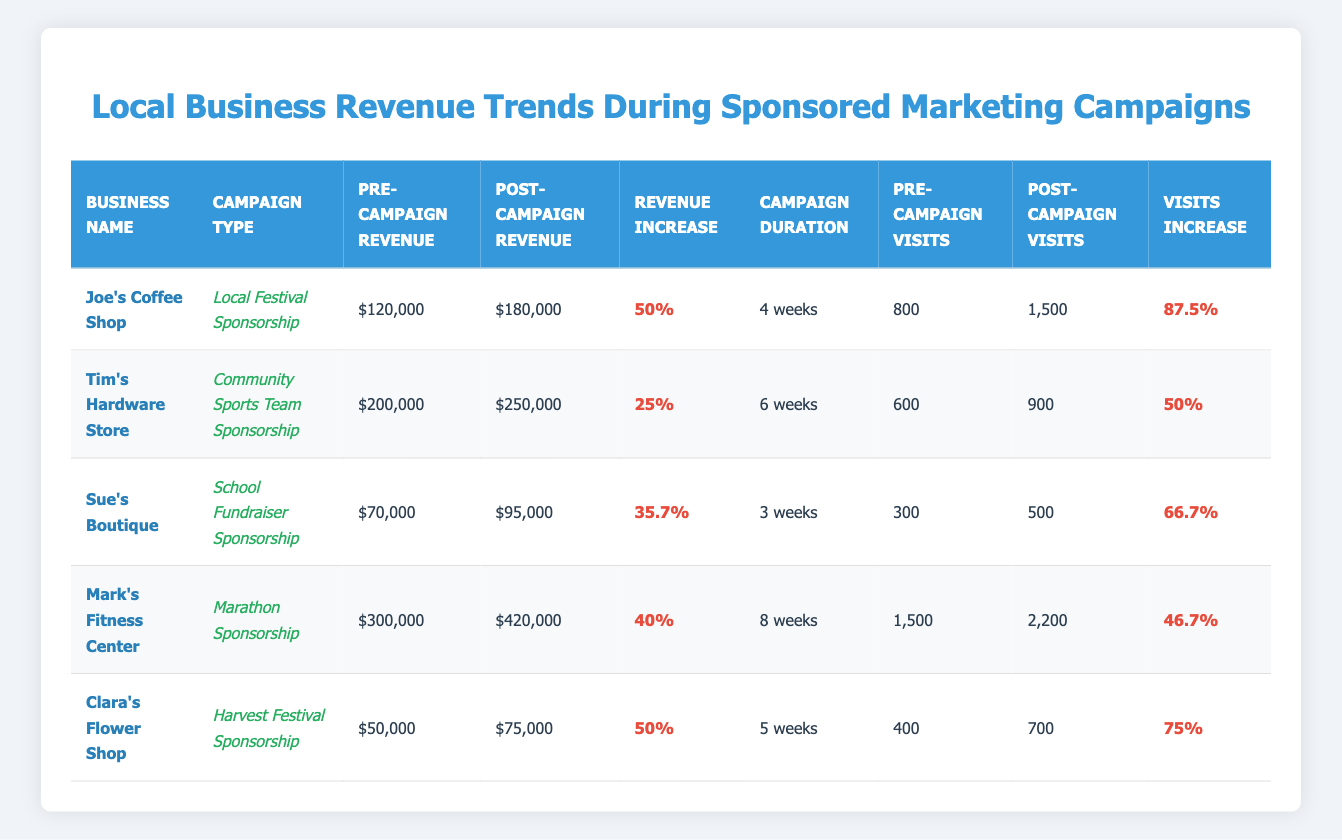What was the pre-campaign revenue for Joe's Coffee Shop? The table clearly shows that Joe's Coffee Shop had a pre-campaign revenue of $120,000 in the respective column.
Answer: 120000 Which business had the highest increase in customer visits? Observing the "Visits Increase" column, Joe's Coffee Shop shows a significant increase of 87.5%, which is greater than any other business listed.
Answer: Joe's Coffee Shop What is the average revenue increase percentage across all businesses? To find the average, we sum the percentages of revenue increases: (50 + 25 + 35.7 + 40 + 50) = 200. There are 5 businesses, so the average revenue increase is 200/5 = 40.
Answer: 40 Does Clara's Flower Shop have a revenue increase greater than 40%? Clara's Flower Shop has a revenue increase of 50%, which is indeed greater than 40%.
Answer: Yes What is the total number of customer visits before and after the campaigns? The total pre-campaign visits are: 800 + 600 + 300 + 1500 + 400 = 3600. The total post-campaign visits are: 1500 + 900 + 500 + 2200 + 700 = 4800.
Answer: Total pre-campaign visits: 3600, Total post-campaign visits: 4800 Which campaign had the longest duration, and what was its increase in revenue? The longest duration campaign is Mark's Fitness Center with 8 weeks. Its revenue increased from $300,000 to $420,000, equating to a 40% increase.
Answer: Marathon Sponsorship, 40% Is the revenue increase for Tim's Hardware Store less than that of Sue's Boutique? Tim's Hardware Store shows a revenue increase of 25%, while Sue's Boutique's revenue increase is 35.7%. Therefore, Tim's revenue increase is less than Sue's.
Answer: Yes What is the difference in revenue between the business with the highest post-campaign revenue and the one with the lowest? The highest post-campaign revenue is Mark's Fitness Center with $420,000 and the lowest is Clara's Flower Shop with $75,000. Thus, the difference is 420,000 - 75,000 = 345,000.
Answer: 345000 What campaign duration correlated with the smallest revenue increase? Looking at the "Revenue Increase" column, Sue's Boutique had a revenue increase of 35.7% and ran a campaign for 3 weeks, which is less than that of other campaigns.
Answer: 3 weeks 